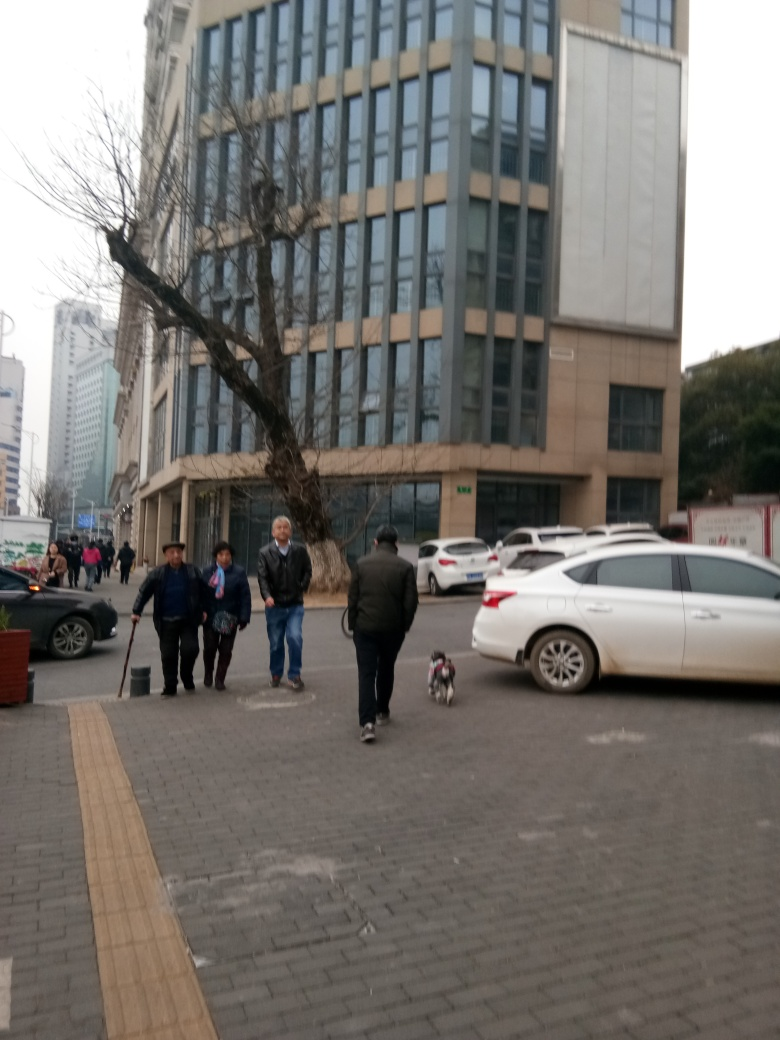Is there anything noteworthy about the architecture in the background? The architecture in the background features a modern building with a series of windows and what appears to be a stone or concrete facade. The grid-like pattern of the windows and uniformity of the design are indicative of contemporary urban office buildings. Does the building seem to serve a specific function? Based on the image, the building's large scale and formal exterior suggest it could be a commercial office building or perhaps a governmental or institutional facility. Without specific signage, it's difficult to determine the exact function. 